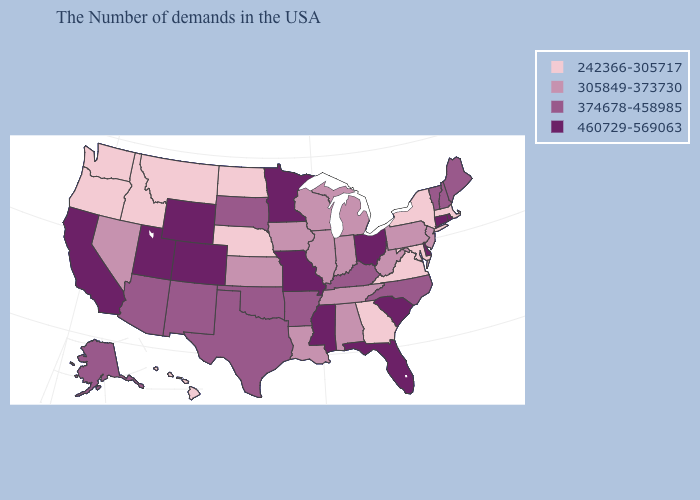Does California have the same value as Maryland?
Concise answer only. No. Name the states that have a value in the range 305849-373730?
Be succinct. New Jersey, Pennsylvania, West Virginia, Michigan, Indiana, Alabama, Tennessee, Wisconsin, Illinois, Louisiana, Iowa, Kansas, Nevada. Name the states that have a value in the range 305849-373730?
Be succinct. New Jersey, Pennsylvania, West Virginia, Michigan, Indiana, Alabama, Tennessee, Wisconsin, Illinois, Louisiana, Iowa, Kansas, Nevada. Name the states that have a value in the range 305849-373730?
Short answer required. New Jersey, Pennsylvania, West Virginia, Michigan, Indiana, Alabama, Tennessee, Wisconsin, Illinois, Louisiana, Iowa, Kansas, Nevada. Name the states that have a value in the range 242366-305717?
Give a very brief answer. Massachusetts, New York, Maryland, Virginia, Georgia, Nebraska, North Dakota, Montana, Idaho, Washington, Oregon, Hawaii. Does Wyoming have the highest value in the USA?
Short answer required. Yes. Does Alabama have the lowest value in the USA?
Keep it brief. No. What is the value of Indiana?
Keep it brief. 305849-373730. What is the lowest value in states that border Kansas?
Write a very short answer. 242366-305717. What is the lowest value in the West?
Keep it brief. 242366-305717. Among the states that border Rhode Island , which have the lowest value?
Write a very short answer. Massachusetts. Which states hav the highest value in the MidWest?
Write a very short answer. Ohio, Missouri, Minnesota. Name the states that have a value in the range 305849-373730?
Answer briefly. New Jersey, Pennsylvania, West Virginia, Michigan, Indiana, Alabama, Tennessee, Wisconsin, Illinois, Louisiana, Iowa, Kansas, Nevada. Is the legend a continuous bar?
Answer briefly. No. What is the lowest value in the USA?
Write a very short answer. 242366-305717. 